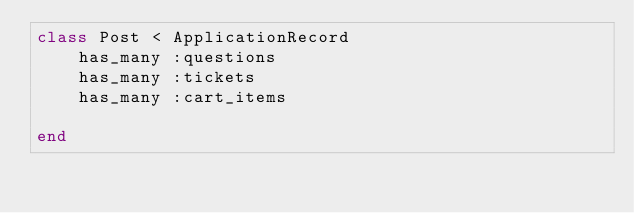<code> <loc_0><loc_0><loc_500><loc_500><_Ruby_>class Post < ApplicationRecord
    has_many :questions
    has_many :tickets
    has_many :cart_items
    
end
</code> 